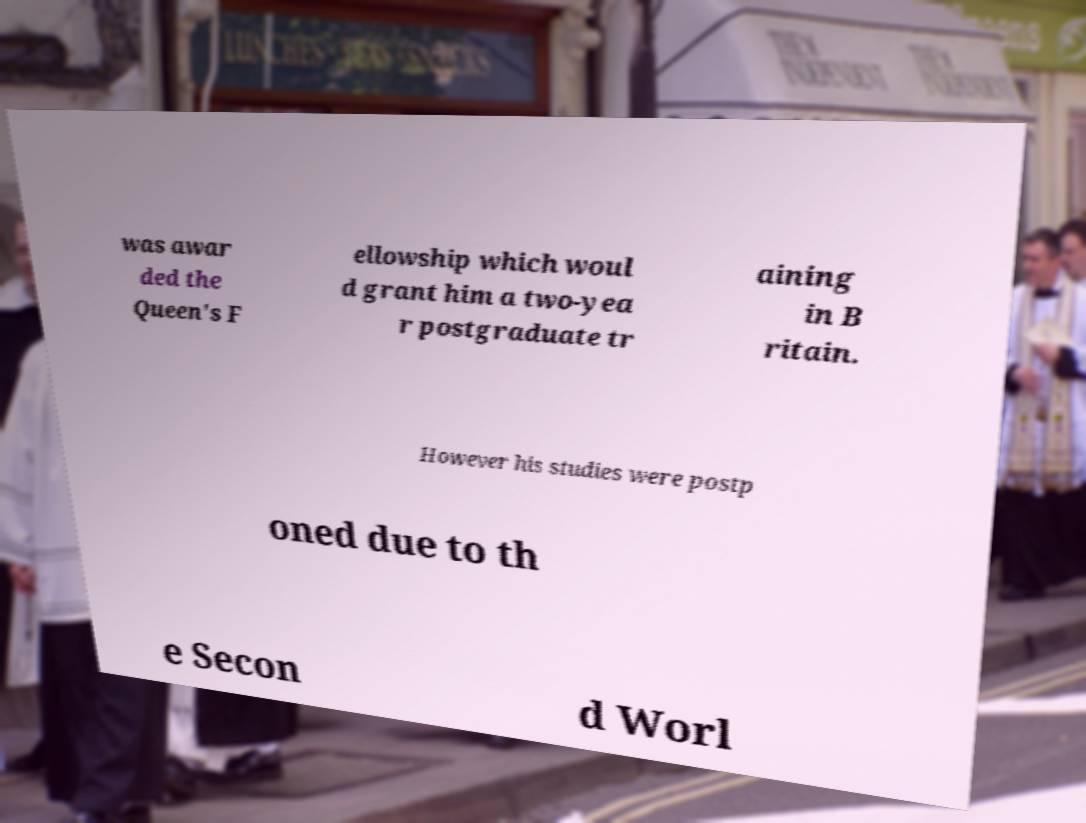I need the written content from this picture converted into text. Can you do that? was awar ded the Queen's F ellowship which woul d grant him a two-yea r postgraduate tr aining in B ritain. However his studies were postp oned due to th e Secon d Worl 